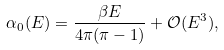Convert formula to latex. <formula><loc_0><loc_0><loc_500><loc_500>\alpha _ { 0 } ( E ) = \frac { \beta E } { 4 \pi ( \pi - 1 ) } + { \mathcal { O } } ( E ^ { 3 } ) ,</formula> 